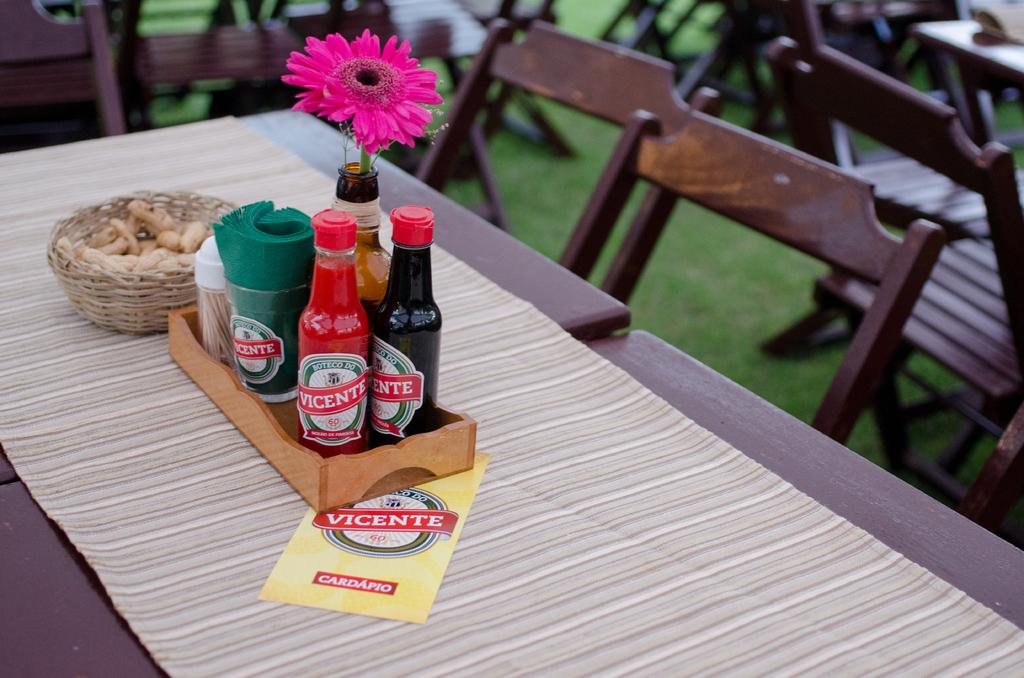<image>
Present a compact description of the photo's key features. Three types of Vicente condiments sit on a table. 